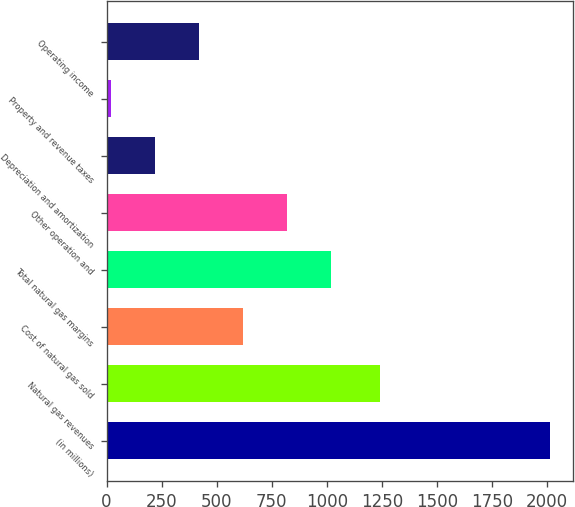Convert chart. <chart><loc_0><loc_0><loc_500><loc_500><bar_chart><fcel>(in millions)<fcel>Natural gas revenues<fcel>Cost of natural gas sold<fcel>Total natural gas margins<fcel>Other operation and<fcel>Depreciation and amortization<fcel>Property and revenue taxes<fcel>Operating income<nl><fcel>2016<fcel>1242.2<fcel>617.61<fcel>1017.15<fcel>817.38<fcel>218.07<fcel>18.3<fcel>417.84<nl></chart> 